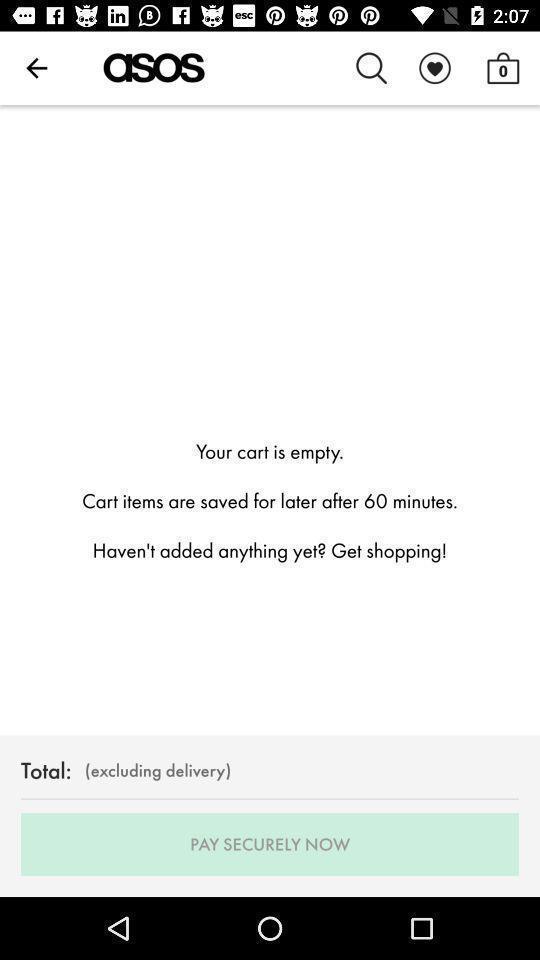Provide a textual representation of this image. Screen displaying your cart is empty. 